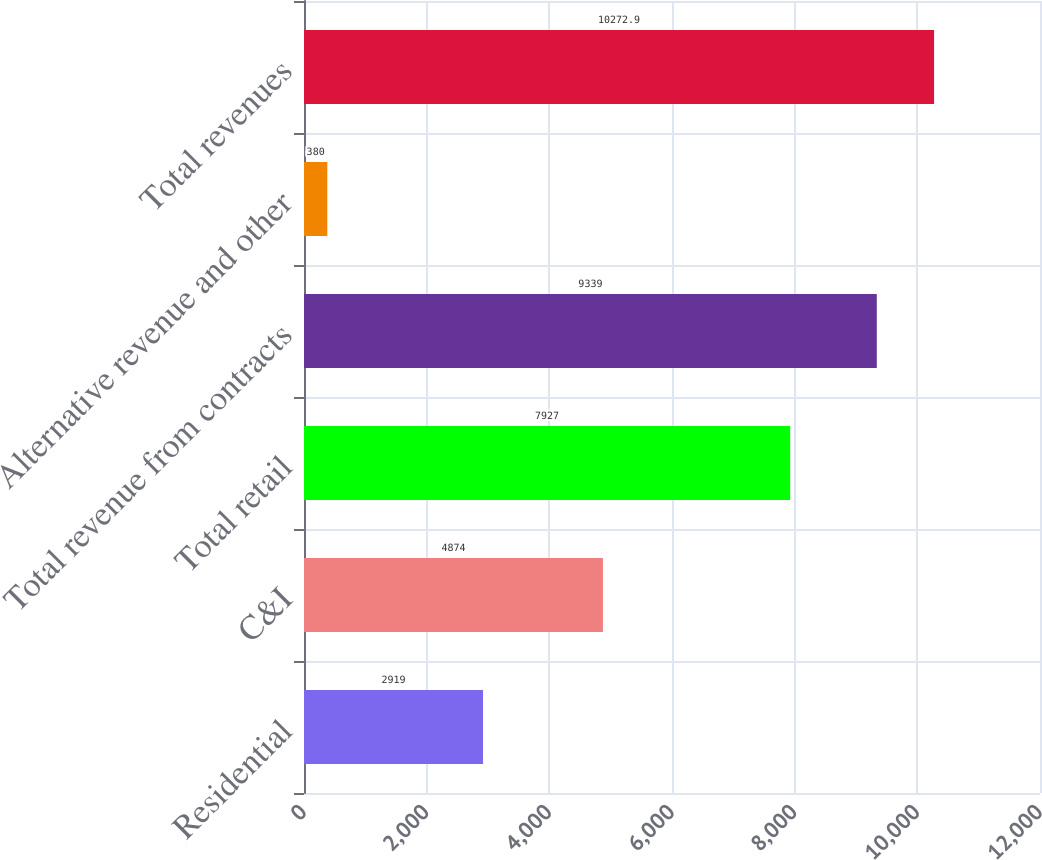<chart> <loc_0><loc_0><loc_500><loc_500><bar_chart><fcel>Residential<fcel>C&I<fcel>Total retail<fcel>Total revenue from contracts<fcel>Alternative revenue and other<fcel>Total revenues<nl><fcel>2919<fcel>4874<fcel>7927<fcel>9339<fcel>380<fcel>10272.9<nl></chart> 